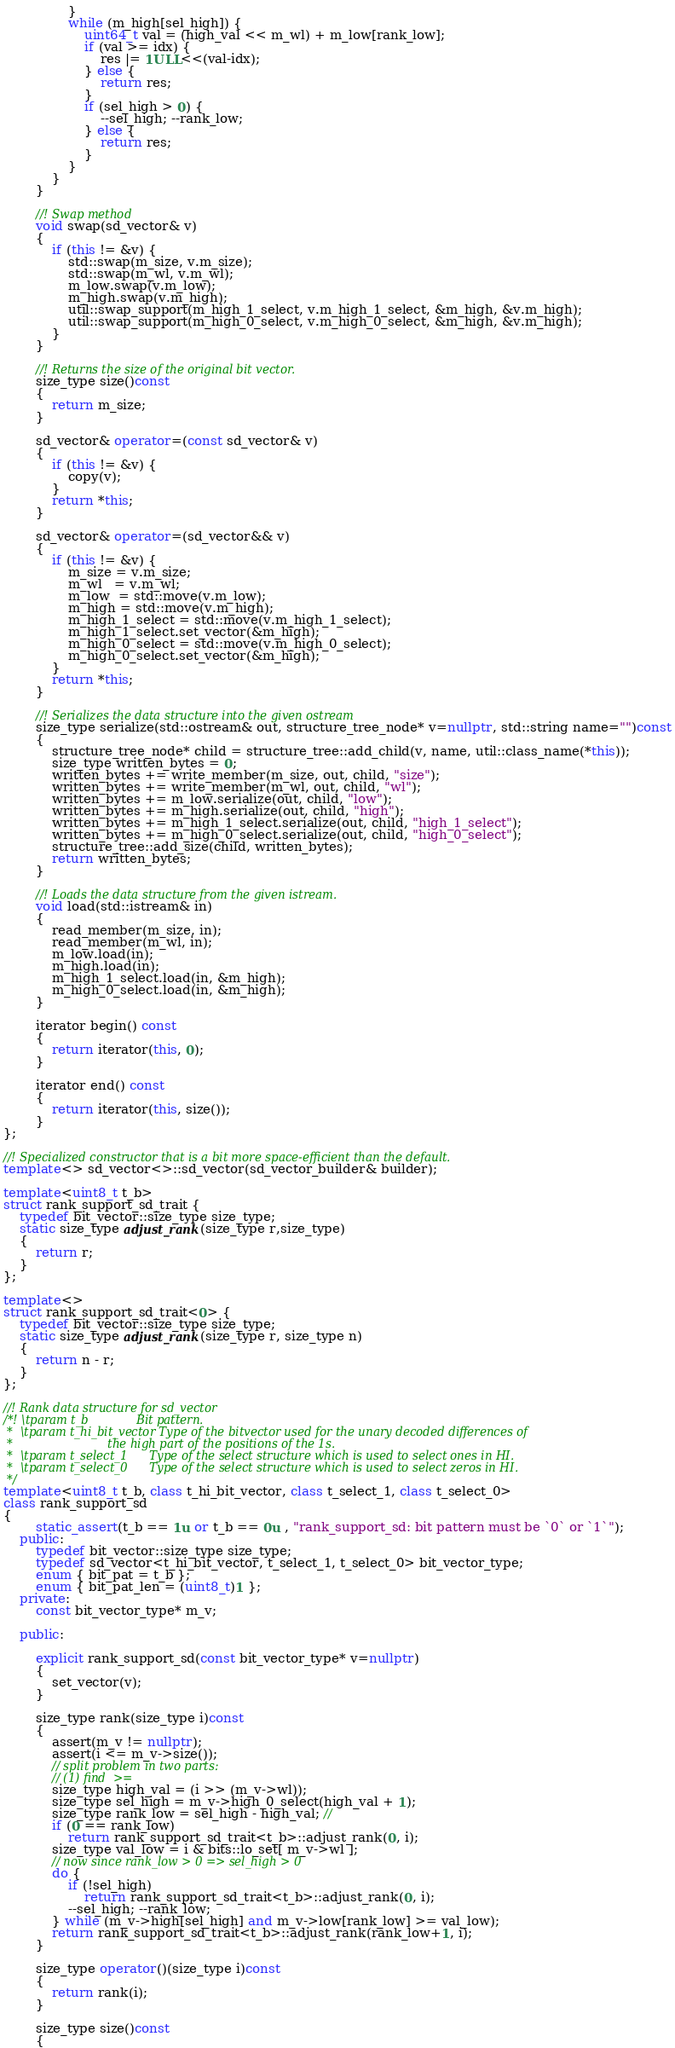Convert code to text. <code><loc_0><loc_0><loc_500><loc_500><_C++_>                }
                while (m_high[sel_high]) {
                    uint64_t val = (high_val << m_wl) + m_low[rank_low];
                    if (val >= idx) {
                        res |= 1ULL<<(val-idx);
                    } else {
                        return res;
                    }
                    if (sel_high > 0) {
                        --sel_high; --rank_low;
                    } else {
                        return res;
                    }
                }
            }
        }

        //! Swap method
        void swap(sd_vector& v)
        {
            if (this != &v) {
                std::swap(m_size, v.m_size);
                std::swap(m_wl, v.m_wl);
                m_low.swap(v.m_low);
                m_high.swap(v.m_high);
                util::swap_support(m_high_1_select, v.m_high_1_select, &m_high, &v.m_high);
                util::swap_support(m_high_0_select, v.m_high_0_select, &m_high, &v.m_high);
            }
        }

        //! Returns the size of the original bit vector.
        size_type size()const
        {
            return m_size;
        }

        sd_vector& operator=(const sd_vector& v)
        {
            if (this != &v) {
                copy(v);
            }
            return *this;
        }

        sd_vector& operator=(sd_vector&& v)
        {
            if (this != &v) {
                m_size = v.m_size;
                m_wl   = v.m_wl;
                m_low  = std::move(v.m_low);
                m_high = std::move(v.m_high);
                m_high_1_select = std::move(v.m_high_1_select);
                m_high_1_select.set_vector(&m_high);
                m_high_0_select = std::move(v.m_high_0_select);
                m_high_0_select.set_vector(&m_high);
            }
            return *this;
        }

        //! Serializes the data structure into the given ostream
        size_type serialize(std::ostream& out, structure_tree_node* v=nullptr, std::string name="")const
        {
            structure_tree_node* child = structure_tree::add_child(v, name, util::class_name(*this));
            size_type written_bytes = 0;
            written_bytes += write_member(m_size, out, child, "size");
            written_bytes += write_member(m_wl, out, child, "wl");
            written_bytes += m_low.serialize(out, child, "low");
            written_bytes += m_high.serialize(out, child, "high");
            written_bytes += m_high_1_select.serialize(out, child, "high_1_select");
            written_bytes += m_high_0_select.serialize(out, child, "high_0_select");
            structure_tree::add_size(child, written_bytes);
            return written_bytes;
        }

        //! Loads the data structure from the given istream.
        void load(std::istream& in)
        {
            read_member(m_size, in);
            read_member(m_wl, in);
            m_low.load(in);
            m_high.load(in);
            m_high_1_select.load(in, &m_high);
            m_high_0_select.load(in, &m_high);
        }

        iterator begin() const
        {
            return iterator(this, 0);
        }

        iterator end() const
        {
            return iterator(this, size());
        }
};

//! Specialized constructor that is a bit more space-efficient than the default.
template<> sd_vector<>::sd_vector(sd_vector_builder& builder);

template<uint8_t t_b>
struct rank_support_sd_trait {
    typedef bit_vector::size_type size_type;
    static size_type adjust_rank(size_type r,size_type)
    {
        return r;
    }
};

template<>
struct rank_support_sd_trait<0> {
    typedef bit_vector::size_type size_type;
    static size_type adjust_rank(size_type r, size_type n)
    {
        return n - r;
    }
};

//! Rank data structure for sd_vector
/*! \tparam t_b             Bit pattern.
 *  \tparam t_hi_bit_vector Type of the bitvector used for the unary decoded differences of
 *                          the high part of the positions of the 1s.
 *  \tparam t_select_1      Type of the select structure which is used to select ones in HI.
 *  \tparam t_select_0      Type of the select structure which is used to select zeros in HI.
 */
template<uint8_t t_b, class t_hi_bit_vector, class t_select_1, class t_select_0>
class rank_support_sd
{
        static_assert(t_b == 1u or t_b == 0u , "rank_support_sd: bit pattern must be `0` or `1`");
    public:
        typedef bit_vector::size_type size_type;
        typedef sd_vector<t_hi_bit_vector, t_select_1, t_select_0> bit_vector_type;
        enum { bit_pat = t_b };
        enum { bit_pat_len = (uint8_t)1 };
    private:
        const bit_vector_type* m_v;

    public:

        explicit rank_support_sd(const bit_vector_type* v=nullptr)
        {
            set_vector(v);
        }

        size_type rank(size_type i)const
        {
            assert(m_v != nullptr);
            assert(i <= m_v->size());
            // split problem in two parts:
            // (1) find  >=
            size_type high_val = (i >> (m_v->wl));
            size_type sel_high = m_v->high_0_select(high_val + 1);
            size_type rank_low = sel_high - high_val; //
            if (0 == rank_low)
                return rank_support_sd_trait<t_b>::adjust_rank(0, i);
            size_type val_low = i & bits::lo_set[ m_v->wl ];
            // now since rank_low > 0 => sel_high > 0
            do {
                if (!sel_high)
                    return rank_support_sd_trait<t_b>::adjust_rank(0, i);
                --sel_high; --rank_low;
            } while (m_v->high[sel_high] and m_v->low[rank_low] >= val_low);
            return rank_support_sd_trait<t_b>::adjust_rank(rank_low+1, i);
        }

        size_type operator()(size_type i)const
        {
            return rank(i);
        }

        size_type size()const
        {</code> 